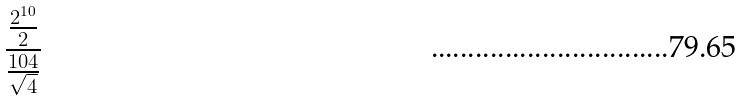Convert formula to latex. <formula><loc_0><loc_0><loc_500><loc_500>\frac { \frac { 2 ^ { 1 0 } } { 2 } } { \frac { 1 0 4 } { \sqrt { 4 } } }</formula> 